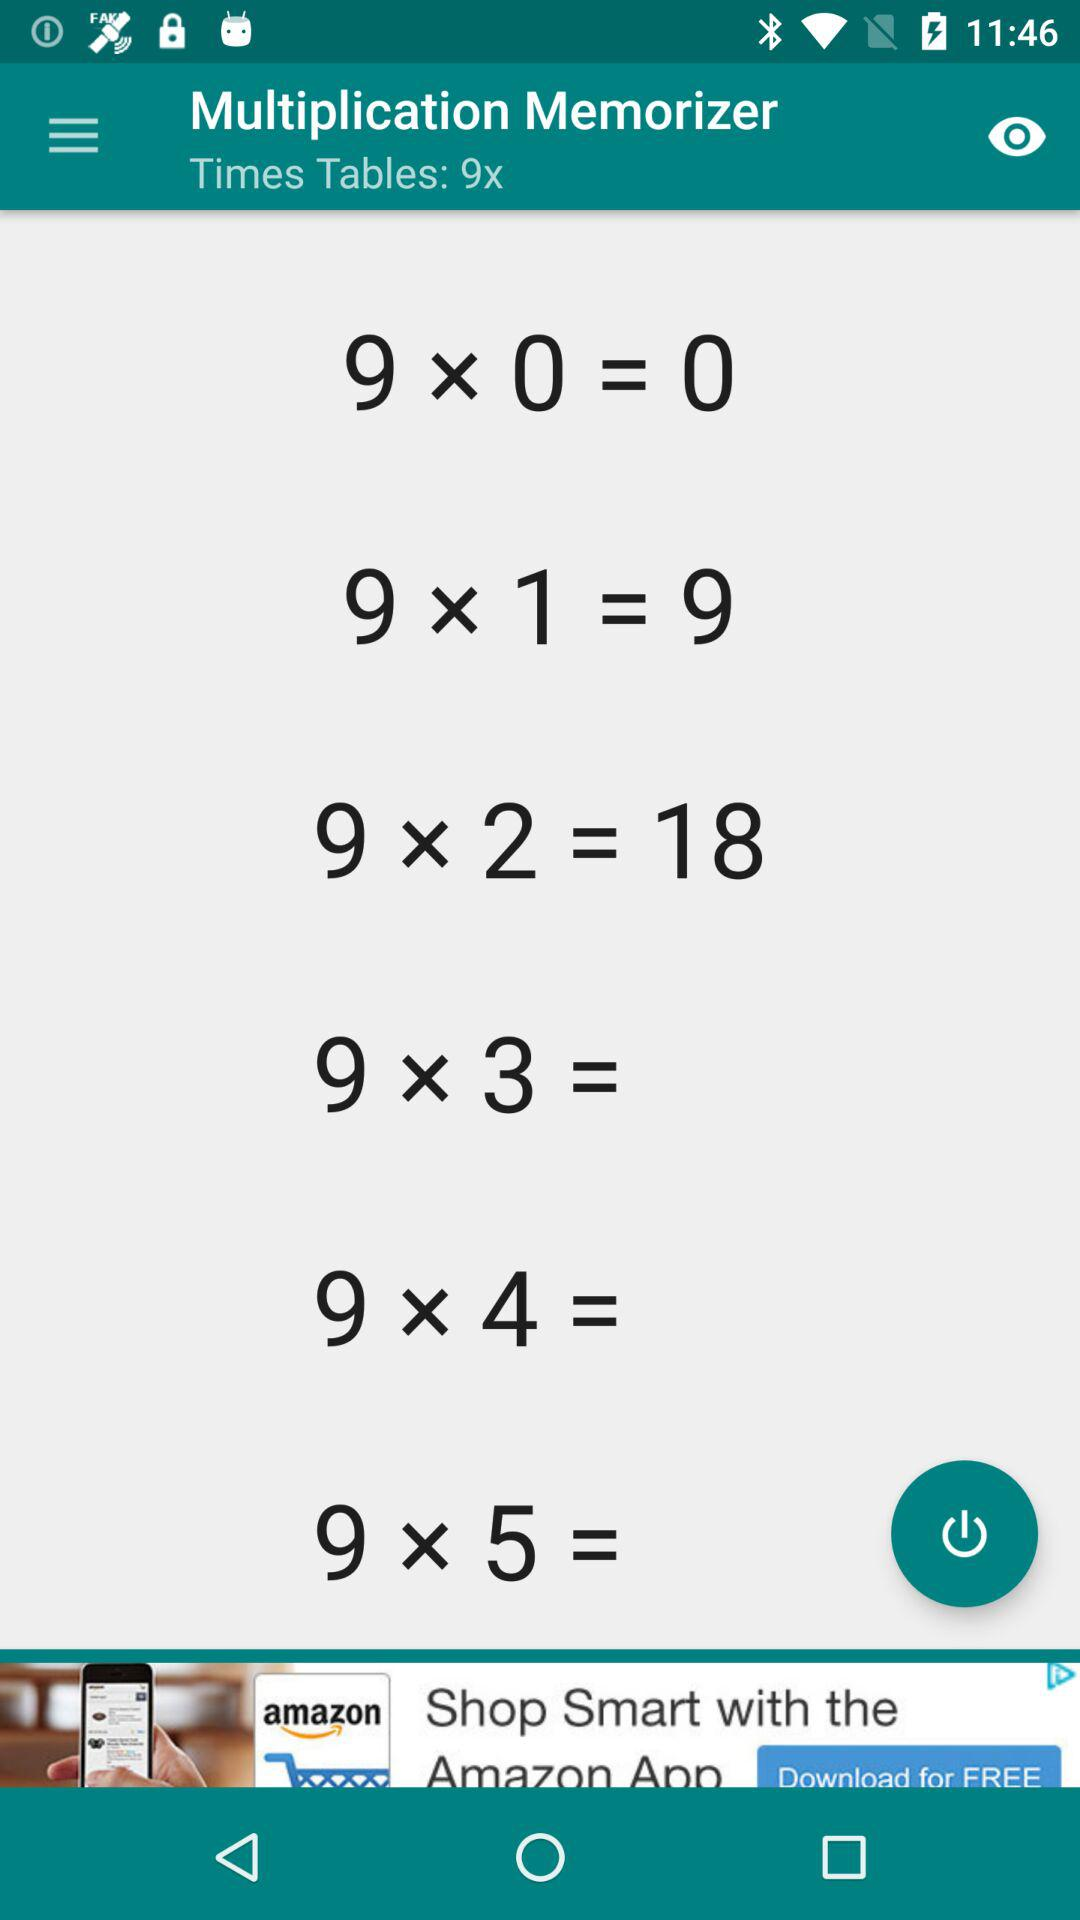How many times tables are displayed?
Answer the question using a single word or phrase. 6 